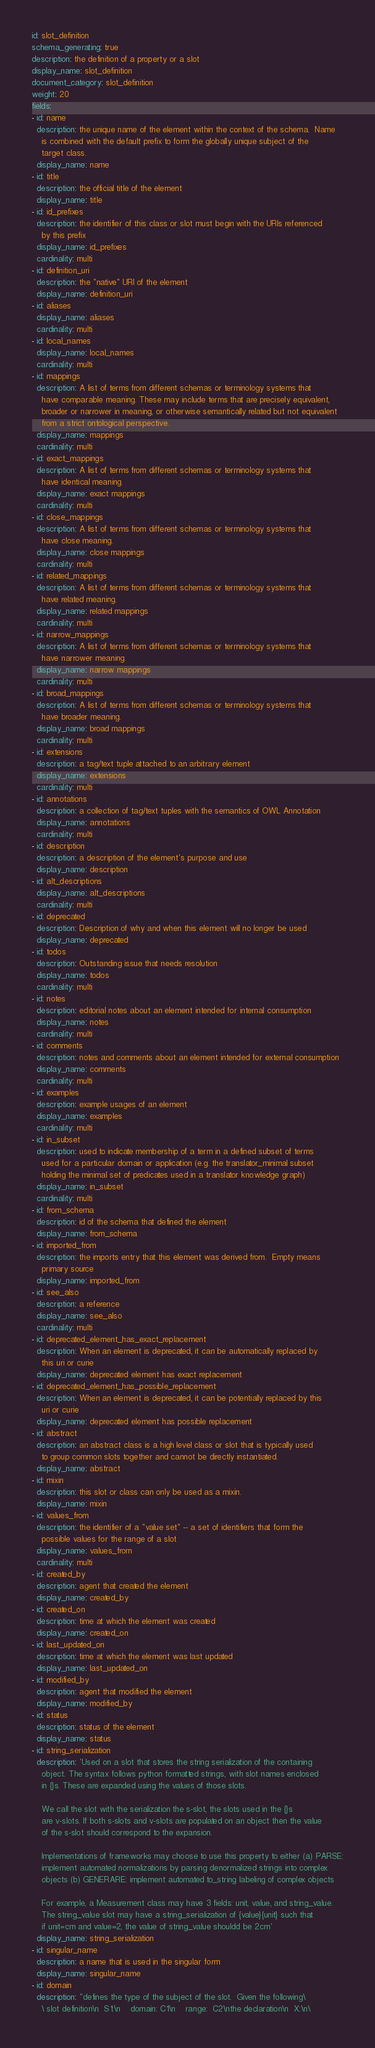Convert code to text. <code><loc_0><loc_0><loc_500><loc_500><_YAML_>id: slot_definition
schema_generating: true
description: the definition of a property or a slot
display_name: slot_definition
document_category: slot_definition
weight: 20
fields:
- id: name
  description: the unique name of the element within the context of the schema.  Name
    is combined with the default prefix to form the globally unique subject of the
    target class.
  display_name: name
- id: title
  description: the official title of the element
  display_name: title
- id: id_prefixes
  description: the identifier of this class or slot must begin with the URIs referenced
    by this prefix
  display_name: id_prefixes
  cardinality: multi
- id: definition_uri
  description: the "native" URI of the element
  display_name: definition_uri
- id: aliases
  display_name: aliases
  cardinality: multi
- id: local_names
  display_name: local_names
  cardinality: multi
- id: mappings
  description: A list of terms from different schemas or terminology systems that
    have comparable meaning. These may include terms that are precisely equivalent,
    broader or narrower in meaning, or otherwise semantically related but not equivalent
    from a strict ontological perspective.
  display_name: mappings
  cardinality: multi
- id: exact_mappings
  description: A list of terms from different schemas or terminology systems that
    have identical meaning.
  display_name: exact mappings
  cardinality: multi
- id: close_mappings
  description: A list of terms from different schemas or terminology systems that
    have close meaning.
  display_name: close mappings
  cardinality: multi
- id: related_mappings
  description: A list of terms from different schemas or terminology systems that
    have related meaning.
  display_name: related mappings
  cardinality: multi
- id: narrow_mappings
  description: A list of terms from different schemas or terminology systems that
    have narrower meaning.
  display_name: narrow mappings
  cardinality: multi
- id: broad_mappings
  description: A list of terms from different schemas or terminology systems that
    have broader meaning.
  display_name: broad mappings
  cardinality: multi
- id: extensions
  description: a tag/text tuple attached to an arbitrary element
  display_name: extensions
  cardinality: multi
- id: annotations
  description: a collection of tag/text tuples with the semantics of OWL Annotation
  display_name: annotations
  cardinality: multi
- id: description
  description: a description of the element's purpose and use
  display_name: description
- id: alt_descriptions
  display_name: alt_descriptions
  cardinality: multi
- id: deprecated
  description: Description of why and when this element will no longer be used
  display_name: deprecated
- id: todos
  description: Outstanding issue that needs resolution
  display_name: todos
  cardinality: multi
- id: notes
  description: editorial notes about an element intended for internal consumption
  display_name: notes
  cardinality: multi
- id: comments
  description: notes and comments about an element intended for external consumption
  display_name: comments
  cardinality: multi
- id: examples
  description: example usages of an element
  display_name: examples
  cardinality: multi
- id: in_subset
  description: used to indicate membership of a term in a defined subset of terms
    used for a particular domain or application (e.g. the translator_minimal subset
    holding the minimal set of predicates used in a translator knowledge graph)
  display_name: in_subset
  cardinality: multi
- id: from_schema
  description: id of the schema that defined the element
  display_name: from_schema
- id: imported_from
  description: the imports entry that this element was derived from.  Empty means
    primary source
  display_name: imported_from
- id: see_also
  description: a reference
  display_name: see_also
  cardinality: multi
- id: deprecated_element_has_exact_replacement
  description: When an element is deprecated, it can be automatically replaced by
    this uri or curie
  display_name: deprecated element has exact replacement
- id: deprecated_element_has_possible_replacement
  description: When an element is deprecated, it can be potentially replaced by this
    uri or curie
  display_name: deprecated element has possible replacement
- id: abstract
  description: an abstract class is a high level class or slot that is typically used
    to group common slots together and cannot be directly instantiated.
  display_name: abstract
- id: mixin
  description: this slot or class can only be used as a mixin.
  display_name: mixin
- id: values_from
  description: the identifier of a "value set" -- a set of identifiers that form the
    possible values for the range of a slot
  display_name: values_from
  cardinality: multi
- id: created_by
  description: agent that created the element
  display_name: created_by
- id: created_on
  description: time at which the element was created
  display_name: created_on
- id: last_updated_on
  description: time at which the element was last updated
  display_name: last_updated_on
- id: modified_by
  description: agent that modified the element
  display_name: modified_by
- id: status
  description: status of the element
  display_name: status
- id: string_serialization
  description: 'Used on a slot that stores the string serialization of the containing
    object. The syntax follows python formatted strings, with slot names enclosed
    in {}s. These are expanded using the values of those slots.

    We call the slot with the serialization the s-slot, the slots used in the {}s
    are v-slots. If both s-slots and v-slots are populated on an object then the value
    of the s-slot should correspond to the expansion.

    Implementations of frameworks may choose to use this property to either (a) PARSE:
    implement automated normalizations by parsing denormalized strings into complex
    objects (b) GENERARE: implement automated to_string labeling of complex objects

    For example, a Measurement class may have 3 fields: unit, value, and string_value.
    The string_value slot may have a string_serialization of {value}{unit} such that
    if unit=cm and value=2, the value of string_value shouldd be 2cm'
  display_name: string_serialization
- id: singular_name
  description: a name that is used in the singular form
  display_name: singular_name
- id: domain
  description: "defines the type of the subject of the slot.  Given the following\
    \ slot definition\n  S1:\n    domain: C1\n    range:  C2\nthe declaration\n  X:\n\</code> 